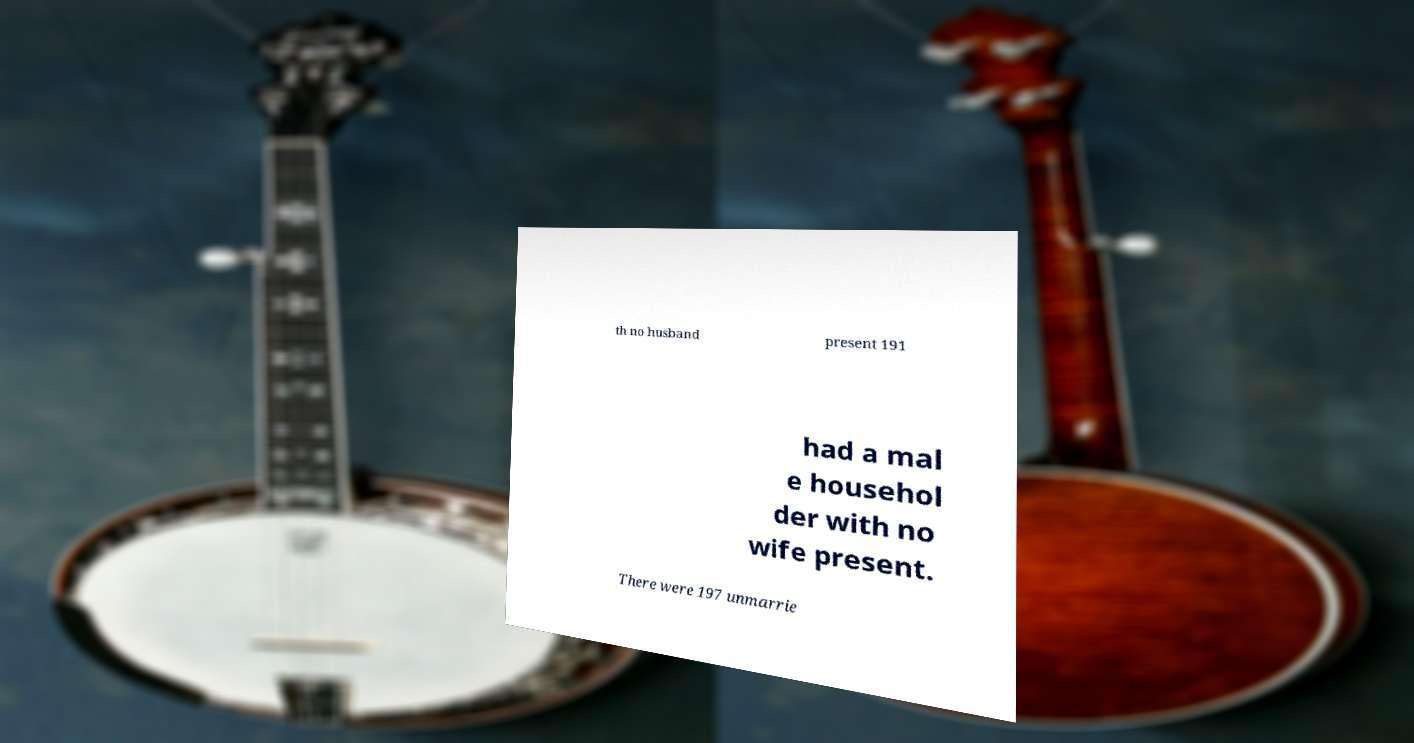What messages or text are displayed in this image? I need them in a readable, typed format. th no husband present 191 had a mal e househol der with no wife present. There were 197 unmarrie 